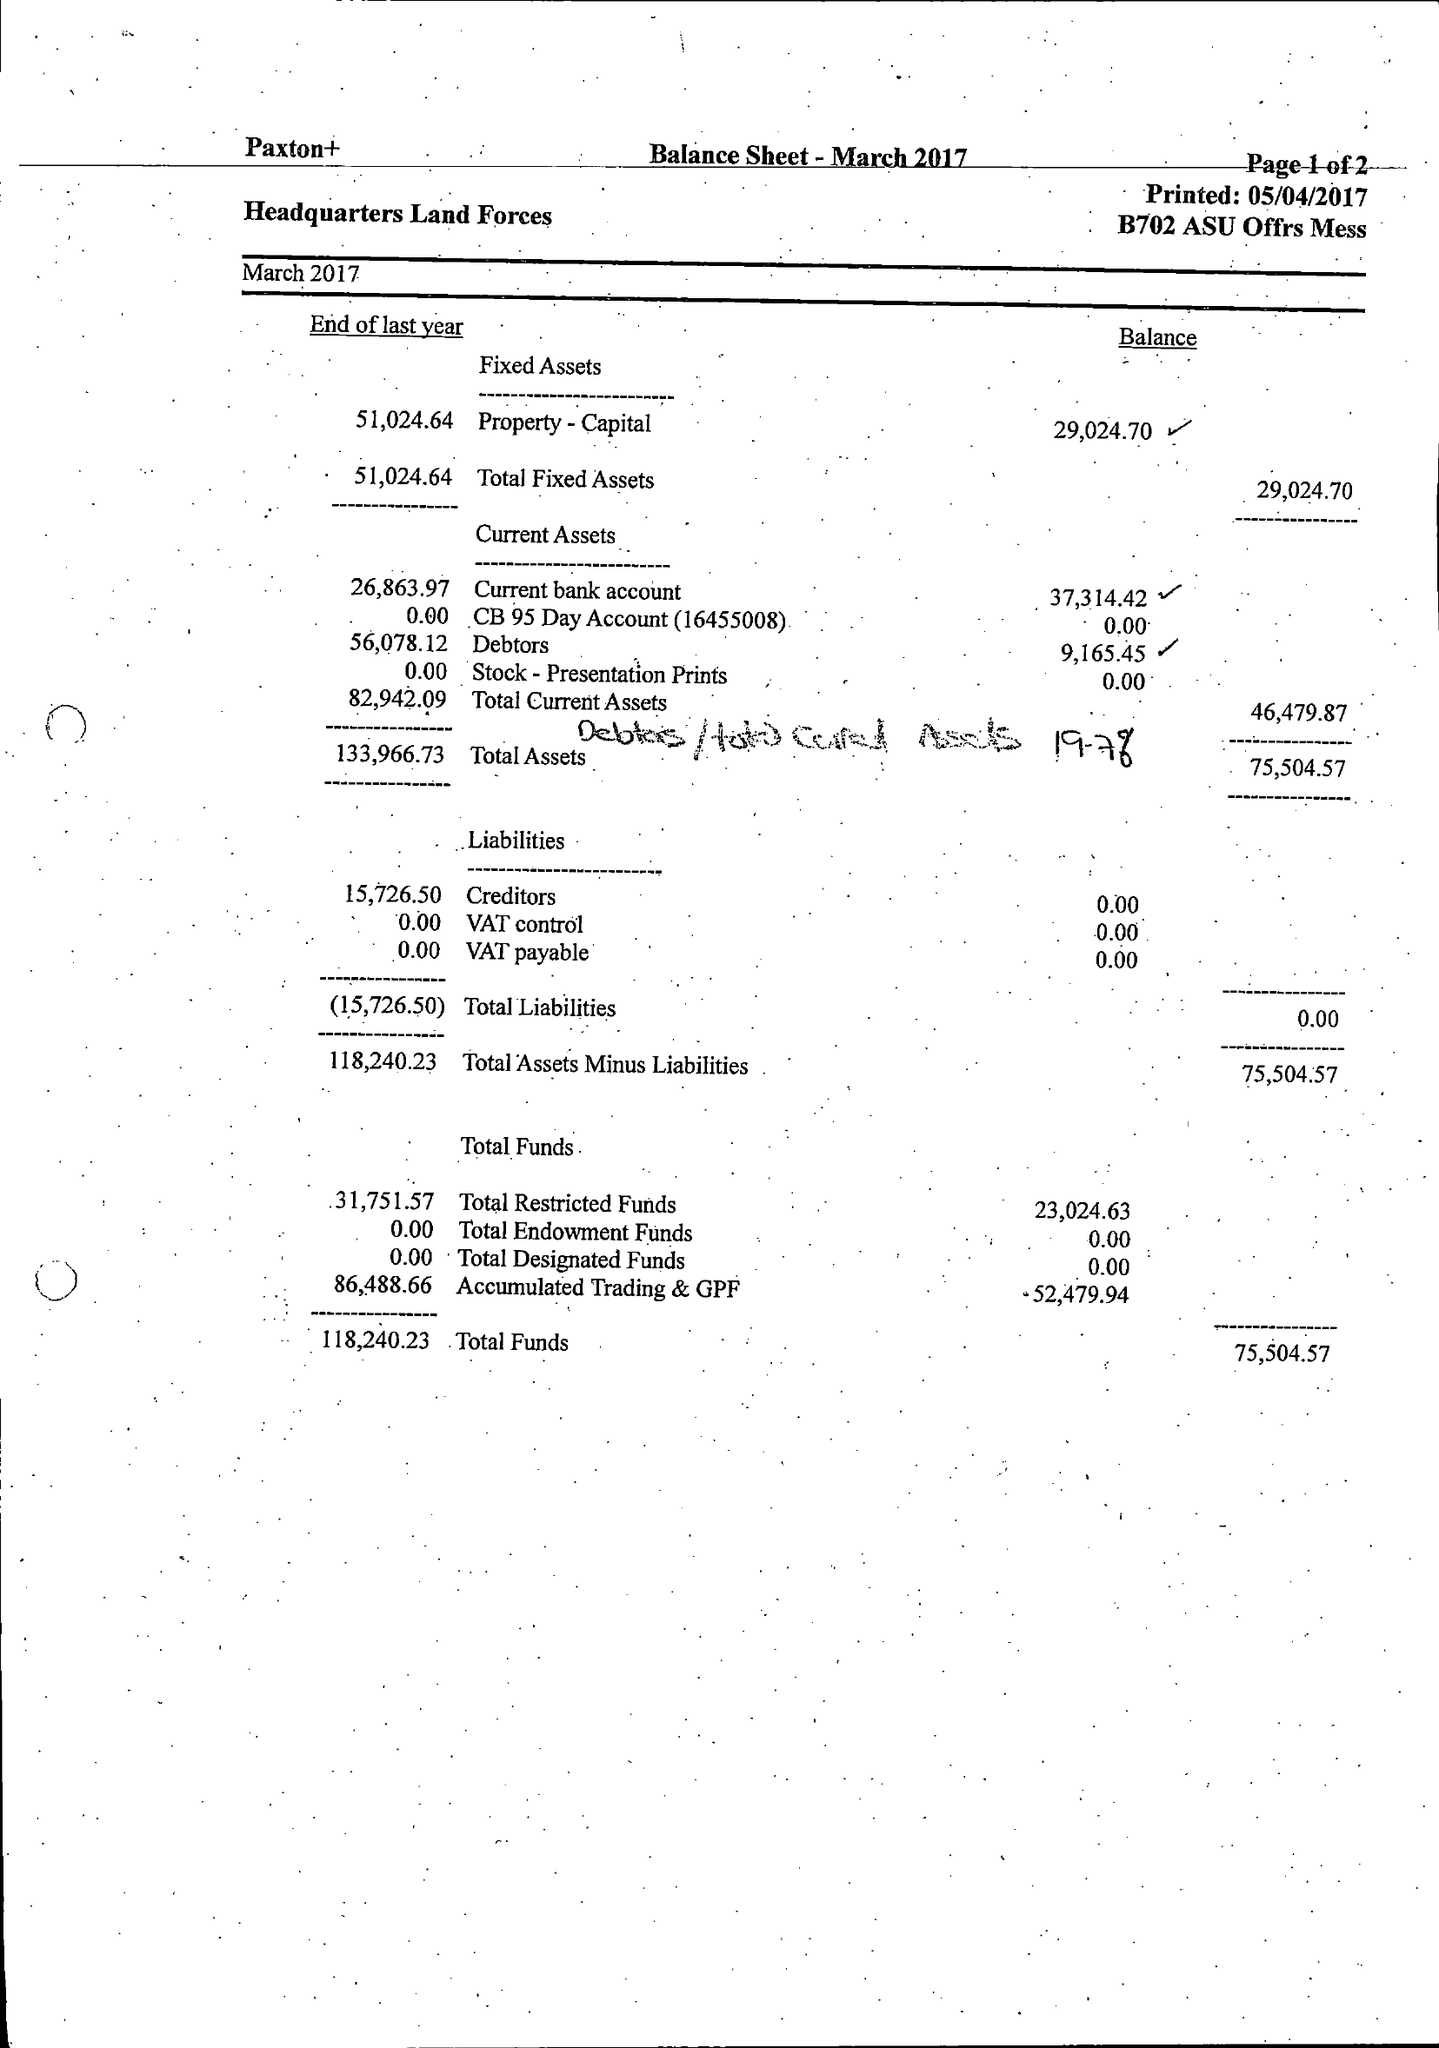What is the value for the address__post_town?
Answer the question using a single word or phrase. ANDOVER 